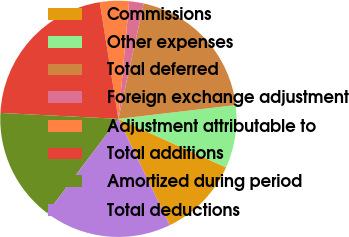Convert chart. <chart><loc_0><loc_0><loc_500><loc_500><pie_chart><fcel>Commissions<fcel>Other expenses<fcel>Total deferred<fcel>Foreign exchange adjustment<fcel>Adjustment attributable to<fcel>Total additions<fcel>Amortized during period<fcel>Total deductions<nl><fcel>11.1%<fcel>8.6%<fcel>19.7%<fcel>1.99%<fcel>3.98%<fcel>21.68%<fcel>15.49%<fcel>17.47%<nl></chart> 